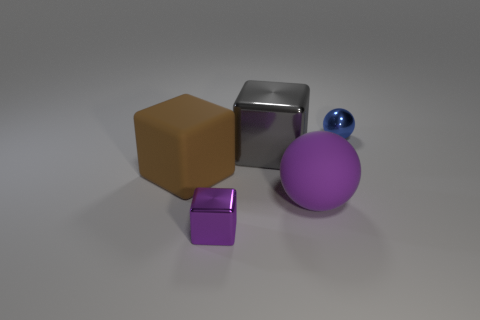Subtract all large blocks. How many blocks are left? 1 Subtract 2 balls. How many balls are left? 0 Add 1 tiny green blocks. How many objects exist? 6 Subtract all spheres. How many objects are left? 3 Add 5 blocks. How many blocks are left? 8 Add 1 large brown objects. How many large brown objects exist? 2 Subtract all brown cubes. How many cubes are left? 2 Subtract 1 brown blocks. How many objects are left? 4 Subtract all blue blocks. Subtract all purple cylinders. How many blocks are left? 3 Subtract all purple cylinders. How many yellow balls are left? 0 